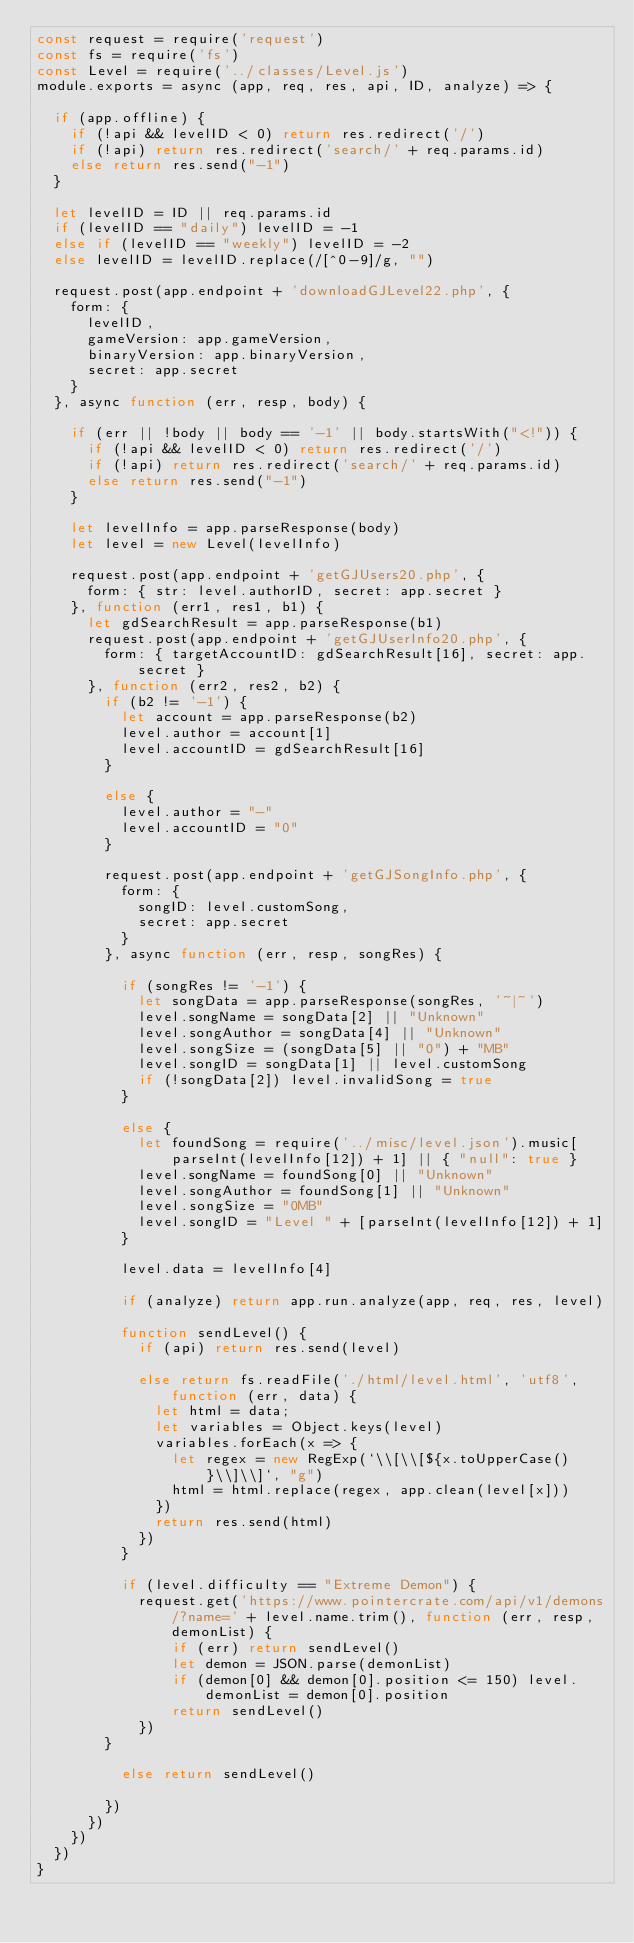Convert code to text. <code><loc_0><loc_0><loc_500><loc_500><_JavaScript_>const request = require('request')
const fs = require('fs')
const Level = require('../classes/Level.js')
module.exports = async (app, req, res, api, ID, analyze) => {

  if (app.offline) {
    if (!api && levelID < 0) return res.redirect('/')
    if (!api) return res.redirect('search/' + req.params.id)
    else return res.send("-1")
  }

  let levelID = ID || req.params.id
  if (levelID == "daily") levelID = -1
  else if (levelID == "weekly") levelID = -2
  else levelID = levelID.replace(/[^0-9]/g, "")

  request.post(app.endpoint + 'downloadGJLevel22.php', {
    form: {
      levelID,
      gameVersion: app.gameVersion,
      binaryVersion: app.binaryVersion,
      secret: app.secret
    }
  }, async function (err, resp, body) {

    if (err || !body || body == '-1' || body.startsWith("<!")) {
      if (!api && levelID < 0) return res.redirect('/')
      if (!api) return res.redirect('search/' + req.params.id)
      else return res.send("-1")
    }

    let levelInfo = app.parseResponse(body)
    let level = new Level(levelInfo)

    request.post(app.endpoint + 'getGJUsers20.php', {
      form: { str: level.authorID, secret: app.secret }
    }, function (err1, res1, b1) {
      let gdSearchResult = app.parseResponse(b1)
      request.post(app.endpoint + 'getGJUserInfo20.php', {
        form: { targetAccountID: gdSearchResult[16], secret: app.secret }
      }, function (err2, res2, b2) {
        if (b2 != '-1') {
          let account = app.parseResponse(b2)
          level.author = account[1]
          level.accountID = gdSearchResult[16]
        }

        else {
          level.author = "-"
          level.accountID = "0"
        }

        request.post(app.endpoint + 'getGJSongInfo.php', {
          form: {
            songID: level.customSong,
            secret: app.secret
          }
        }, async function (err, resp, songRes) {

          if (songRes != '-1') {
            let songData = app.parseResponse(songRes, '~|~')
            level.songName = songData[2] || "Unknown"
            level.songAuthor = songData[4] || "Unknown"
            level.songSize = (songData[5] || "0") + "MB"
            level.songID = songData[1] || level.customSong
            if (!songData[2]) level.invalidSong = true
          }

          else {
            let foundSong = require('../misc/level.json').music[parseInt(levelInfo[12]) + 1] || { "null": true }
            level.songName = foundSong[0] || "Unknown"
            level.songAuthor = foundSong[1] || "Unknown"
            level.songSize = "0MB"
            level.songID = "Level " + [parseInt(levelInfo[12]) + 1]
          }

          level.data = levelInfo[4]

          if (analyze) return app.run.analyze(app, req, res, level)

          function sendLevel() {
            if (api) return res.send(level)

            else return fs.readFile('./html/level.html', 'utf8', function (err, data) {
              let html = data;
              let variables = Object.keys(level)
              variables.forEach(x => {
                let regex = new RegExp(`\\[\\[${x.toUpperCase()}\\]\\]`, "g")
                html = html.replace(regex, app.clean(level[x]))
              })
              return res.send(html)
            })
          }

          if (level.difficulty == "Extreme Demon") {
            request.get('https://www.pointercrate.com/api/v1/demons/?name=' + level.name.trim(), function (err, resp, demonList) {
                if (err) return sendLevel()
                let demon = JSON.parse(demonList)
                if (demon[0] && demon[0].position <= 150) level.demonList = demon[0].position
                return sendLevel()
            })
        }

          else return sendLevel()

        })
      })
    })
  })
}</code> 